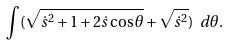<formula> <loc_0><loc_0><loc_500><loc_500>\int ( \sqrt { \dot { s } ^ { 2 } + 1 + 2 \dot { s } \cos \theta } + \sqrt { \dot { s } ^ { 2 } } ) \ d \theta .</formula> 